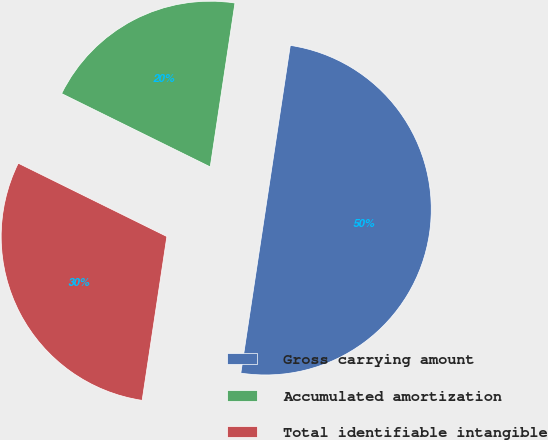Convert chart to OTSL. <chart><loc_0><loc_0><loc_500><loc_500><pie_chart><fcel>Gross carrying amount<fcel>Accumulated amortization<fcel>Total identifiable intangible<nl><fcel>50.0%<fcel>20.09%<fcel>29.91%<nl></chart> 